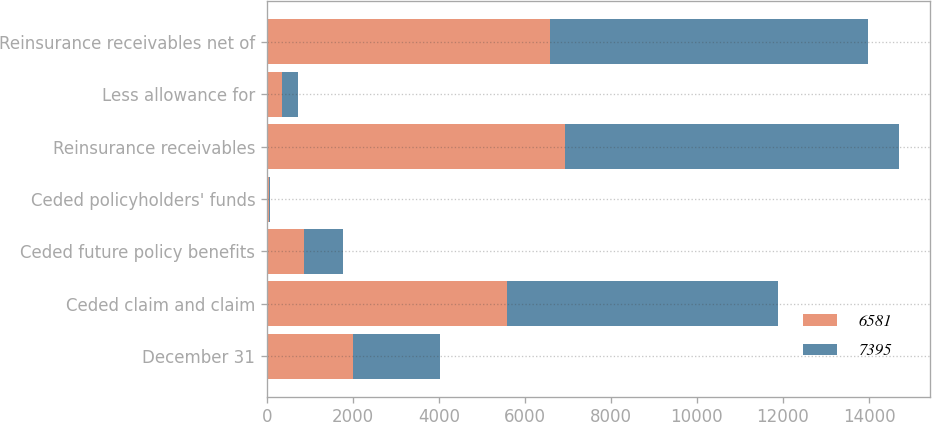<chart> <loc_0><loc_0><loc_500><loc_500><stacked_bar_chart><ecel><fcel>December 31<fcel>Ceded claim and claim<fcel>Ceded future policy benefits<fcel>Ceded policyholders' funds<fcel>Reinsurance receivables<fcel>Less allowance for<fcel>Reinsurance receivables net of<nl><fcel>6581<fcel>2009<fcel>5594<fcel>859<fcel>39<fcel>6932<fcel>351<fcel>6581<nl><fcel>7395<fcel>2008<fcel>6288<fcel>903<fcel>39<fcel>7761<fcel>366<fcel>7395<nl></chart> 